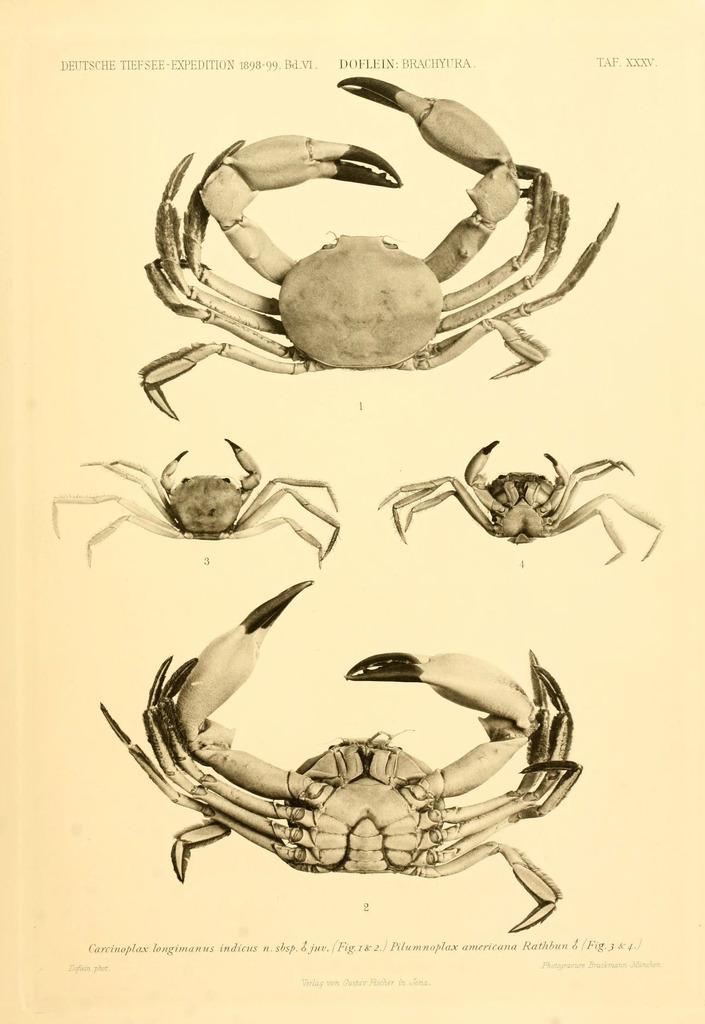In one or two sentences, can you explain what this image depicts? This image consists of a paper with a few images of crab and a text on it. 